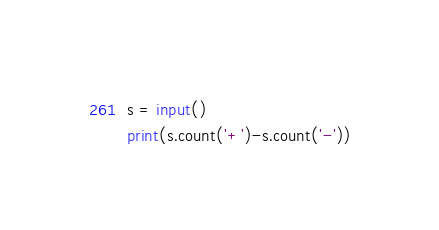<code> <loc_0><loc_0><loc_500><loc_500><_Python_>s = input()
print(s.count('+')-s.count('-'))</code> 